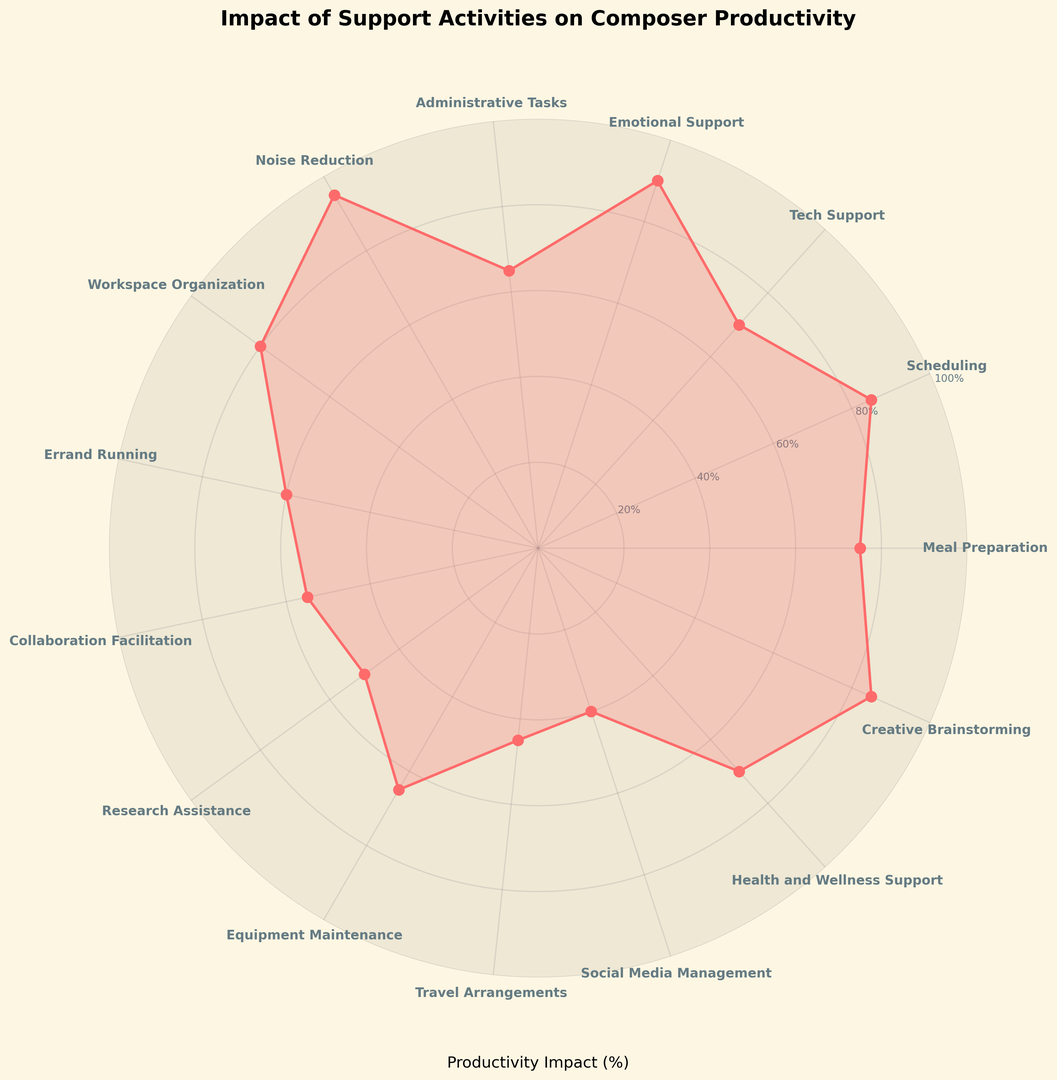What activity has the highest impact on composer productivity? Reviewing the radar chart, the activity with the highest impact is identified by locating the data point with the longest radial distance. Noise Reduction has the highest impact at 95%.
Answer: Noise Reduction What is the difference in productivity impact between Emotional Support and Errand Running? To find the difference, identify the radial distances for both activities: Emotional Support is at 90% and Errand Running is at 60%. Subtract the smaller value from the larger one: 90% - 60% = 30%.
Answer: 30% Which activity has a greater impact on productivity: Tech Support or Social Media Management? Locate both activities on the chart and compare their radial distances. Tech Support has a value of 70%, while Social Media Management has a value of 40%. Tech Support has a greater impact.
Answer: Tech Support What is the average productivity impact of Creative Brainstorming, Health and Wellness Support, and Research Assistance? Calculate the average by summing the impacts and dividing by the number of activities: (85% + 70% + 50%) / 3 = 205% / 3 ≈ 68.33%.
Answer: 68.33% Do Workspace Organization and Administrative Tasks differ significantly in their impact on productivity? Compare the two values: Workspace Organization has an impact of 80%, and Administrative Tasks have an impact of 65%. The difference is 80% - 65% = 15%. This is a moderately significant difference.
Answer: 15% What activities have an impact on productivity below 50%? Identify activities that fall below this threshold by examining the chart. Social Media Management (40%) and Travel Arrangements (45%) meet this criterion.
Answer: Social Media Management, Travel Arrangements Is the productivity impact of Scheduling greater than the average impact of Tech Support and Administrative Tasks? First, find the average impact of Tech Support and Administrative Tasks: (70% + 65%) / 2 = 67.5%. Then, compare this value to Scheduling’s impact of 85%. Scheduling has a greater impact.
Answer: Yes What is the combined productivity impact of Meal Preparation and Emotional Support? Add the productivity impacts of both activities: 75% + 90% = 165%.
Answer: 165% How much greater is the impact of Collaboration Facilitation compared to Travel Arrangements? Compare the two impacts: Collaboration Facilitation has 55%, and Travel Arrangements have 45%. The difference is 55% - 45% = 10%.
Answer: 10% Which activity has the closest productivity impact to Tech Support? Identify the impact of Tech Support at 70% and find the activity with a value closest to 70%. Health and Wellness Support also has a productivity impact of 70%.
Answer: Health and Wellness Support 